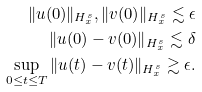<formula> <loc_0><loc_0><loc_500><loc_500>\| u ( 0 ) \| _ { H ^ { s } _ { x } } , \| v ( 0 ) \| _ { H ^ { s } _ { x } } \lesssim \epsilon \\ \| u ( 0 ) - v ( 0 ) \| _ { H ^ { s } _ { x } } \lesssim \delta \\ \sup _ { 0 \leq t \leq T } \| u ( t ) - v ( t ) \| _ { H ^ { s } _ { x } } \gtrsim \epsilon .</formula> 